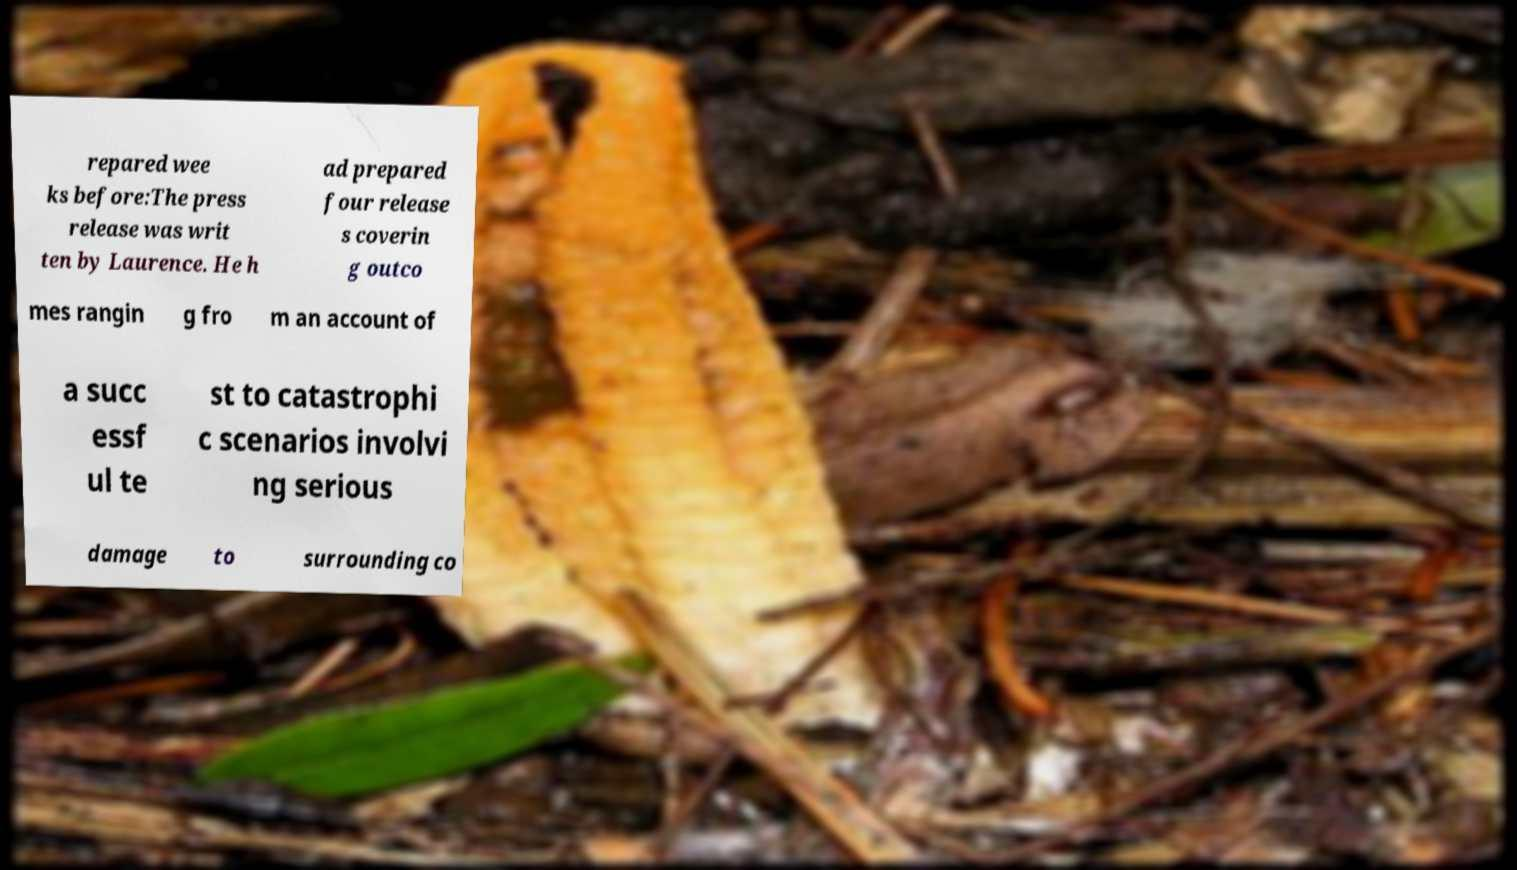Could you assist in decoding the text presented in this image and type it out clearly? repared wee ks before:The press release was writ ten by Laurence. He h ad prepared four release s coverin g outco mes rangin g fro m an account of a succ essf ul te st to catastrophi c scenarios involvi ng serious damage to surrounding co 